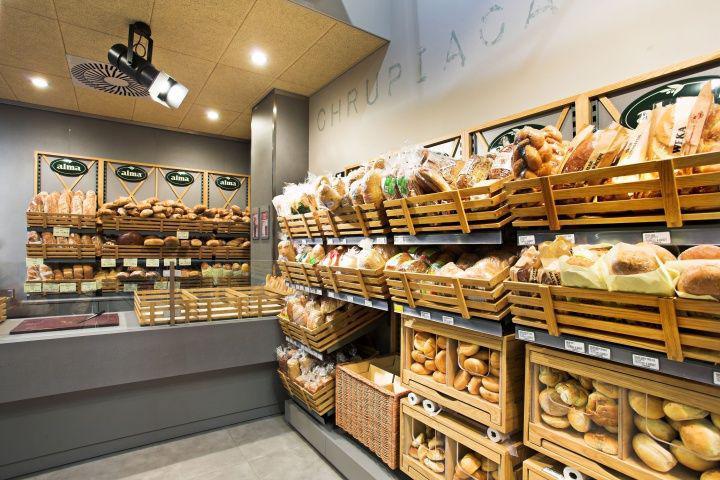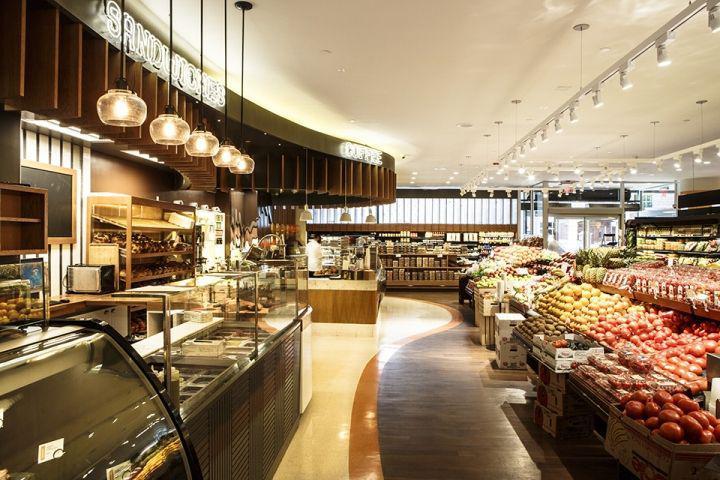The first image is the image on the left, the second image is the image on the right. For the images shown, is this caption "Right image includes a row of at least 3 pendant lights." true? Answer yes or no. Yes. 